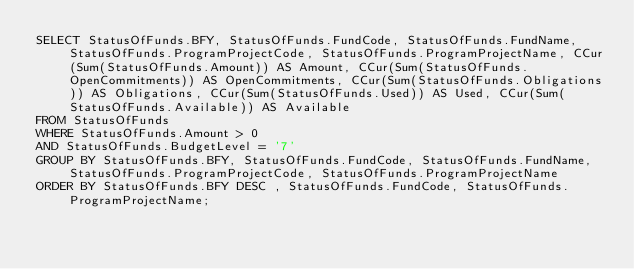Convert code to text. <code><loc_0><loc_0><loc_500><loc_500><_SQL_>SELECT StatusOfFunds.BFY, StatusOfFunds.FundCode, StatusOfFunds.FundName, StatusOfFunds.ProgramProjectCode, StatusOfFunds.ProgramProjectName, CCur(Sum(StatusOfFunds.Amount)) AS Amount, CCur(Sum(StatusOfFunds.OpenCommitments)) AS OpenCommitments, CCur(Sum(StatusOfFunds.Obligations)) AS Obligations, CCur(Sum(StatusOfFunds.Used)) AS Used, CCur(Sum(StatusOfFunds.Available)) AS Available
FROM StatusOfFunds
WHERE StatusOfFunds.Amount > 0
AND StatusOfFunds.BudgetLevel = '7'
GROUP BY StatusOfFunds.BFY, StatusOfFunds.FundCode, StatusOfFunds.FundName, StatusOfFunds.ProgramProjectCode, StatusOfFunds.ProgramProjectName
ORDER BY StatusOfFunds.BFY DESC , StatusOfFunds.FundCode, StatusOfFunds.ProgramProjectName;</code> 